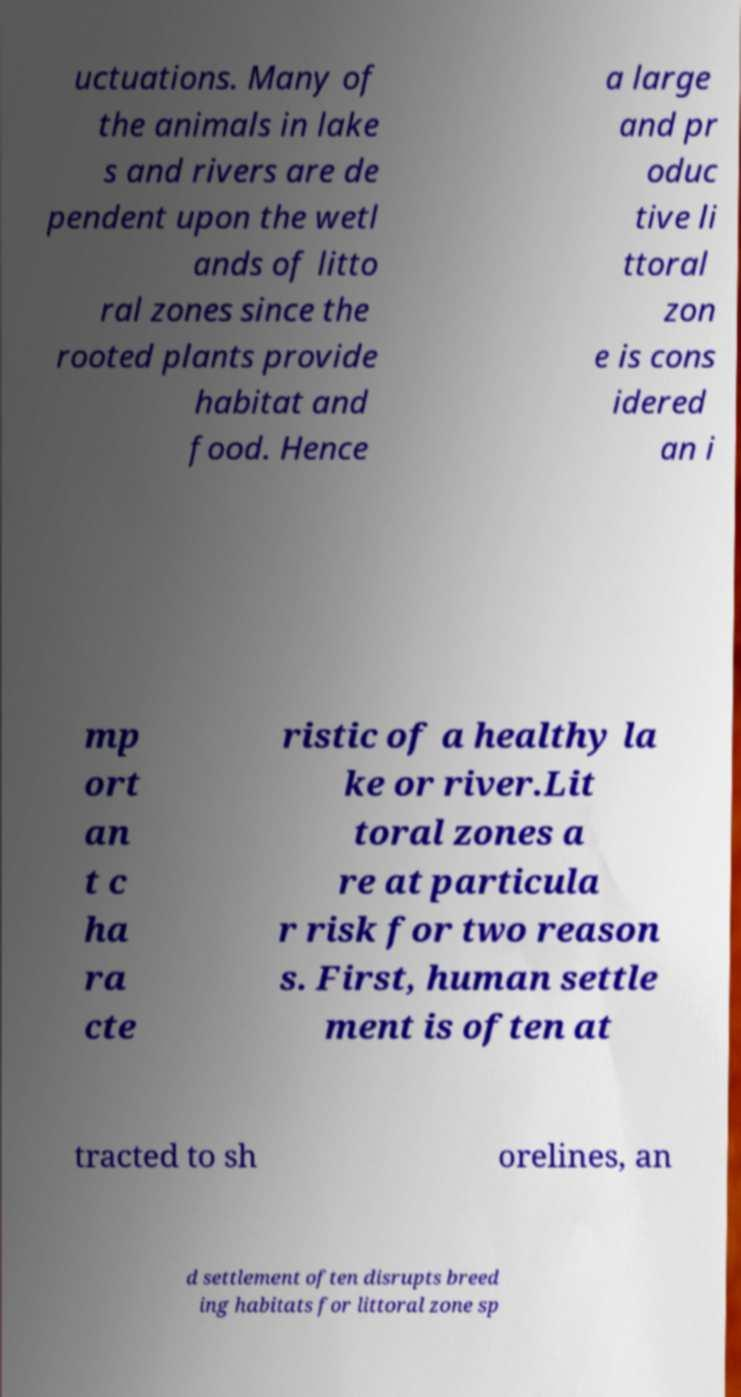For documentation purposes, I need the text within this image transcribed. Could you provide that? uctuations. Many of the animals in lake s and rivers are de pendent upon the wetl ands of litto ral zones since the rooted plants provide habitat and food. Hence a large and pr oduc tive li ttoral zon e is cons idered an i mp ort an t c ha ra cte ristic of a healthy la ke or river.Lit toral zones a re at particula r risk for two reason s. First, human settle ment is often at tracted to sh orelines, an d settlement often disrupts breed ing habitats for littoral zone sp 